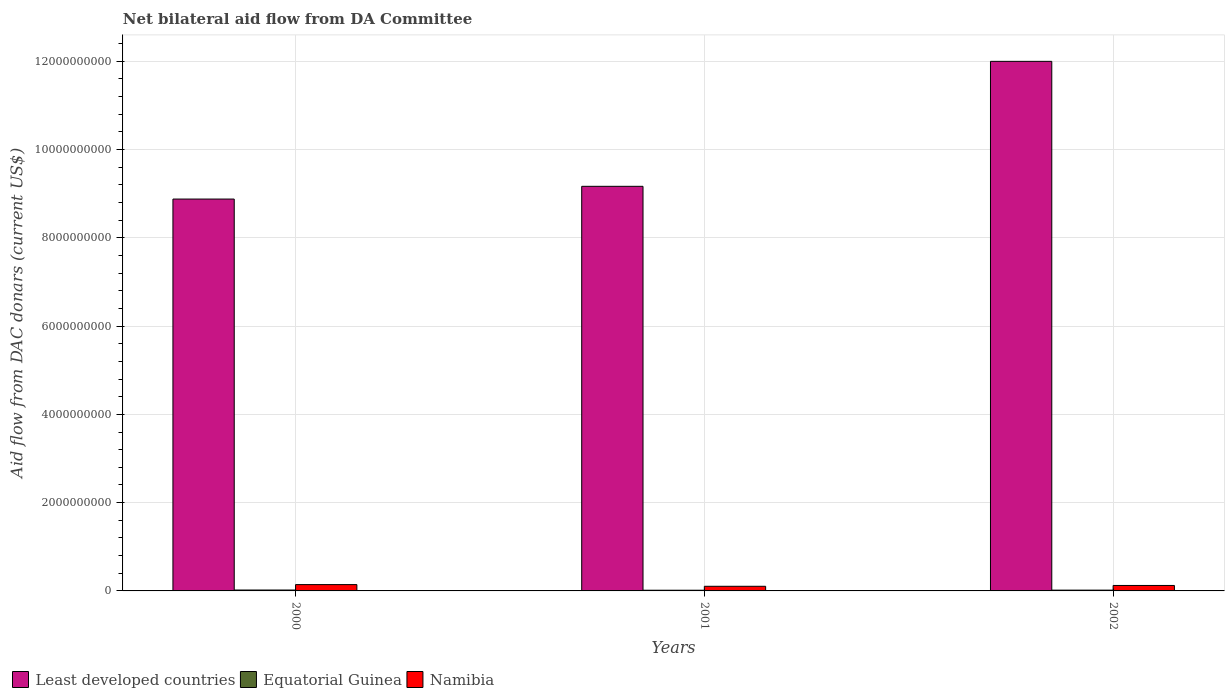How many groups of bars are there?
Offer a very short reply. 3. Are the number of bars per tick equal to the number of legend labels?
Provide a succinct answer. Yes. Are the number of bars on each tick of the X-axis equal?
Make the answer very short. Yes. How many bars are there on the 2nd tick from the left?
Offer a terse response. 3. What is the label of the 1st group of bars from the left?
Your response must be concise. 2000. In how many cases, is the number of bars for a given year not equal to the number of legend labels?
Your response must be concise. 0. What is the aid flow in in Equatorial Guinea in 2002?
Your answer should be compact. 1.77e+07. Across all years, what is the maximum aid flow in in Equatorial Guinea?
Provide a succinct answer. 2.03e+07. Across all years, what is the minimum aid flow in in Equatorial Guinea?
Keep it short and to the point. 1.57e+07. In which year was the aid flow in in Namibia maximum?
Ensure brevity in your answer.  2000. What is the total aid flow in in Least developed countries in the graph?
Your answer should be very brief. 3.00e+1. What is the difference between the aid flow in in Least developed countries in 2001 and that in 2002?
Your answer should be very brief. -2.83e+09. What is the difference between the aid flow in in Least developed countries in 2001 and the aid flow in in Equatorial Guinea in 2002?
Make the answer very short. 9.15e+09. What is the average aid flow in in Equatorial Guinea per year?
Your answer should be compact. 1.79e+07. In the year 2000, what is the difference between the aid flow in in Namibia and aid flow in in Equatorial Guinea?
Keep it short and to the point. 1.23e+08. What is the ratio of the aid flow in in Least developed countries in 2000 to that in 2002?
Your answer should be very brief. 0.74. Is the aid flow in in Equatorial Guinea in 2000 less than that in 2001?
Keep it short and to the point. No. Is the difference between the aid flow in in Namibia in 2001 and 2002 greater than the difference between the aid flow in in Equatorial Guinea in 2001 and 2002?
Provide a succinct answer. No. What is the difference between the highest and the second highest aid flow in in Least developed countries?
Offer a very short reply. 2.83e+09. What is the difference between the highest and the lowest aid flow in in Least developed countries?
Offer a terse response. 3.12e+09. In how many years, is the aid flow in in Least developed countries greater than the average aid flow in in Least developed countries taken over all years?
Make the answer very short. 1. Is the sum of the aid flow in in Equatorial Guinea in 2001 and 2002 greater than the maximum aid flow in in Least developed countries across all years?
Give a very brief answer. No. What does the 1st bar from the left in 2000 represents?
Keep it short and to the point. Least developed countries. What does the 1st bar from the right in 2002 represents?
Make the answer very short. Namibia. Is it the case that in every year, the sum of the aid flow in in Least developed countries and aid flow in in Equatorial Guinea is greater than the aid flow in in Namibia?
Ensure brevity in your answer.  Yes. Are all the bars in the graph horizontal?
Your answer should be very brief. No. What is the difference between two consecutive major ticks on the Y-axis?
Provide a succinct answer. 2.00e+09. Are the values on the major ticks of Y-axis written in scientific E-notation?
Make the answer very short. No. Does the graph contain any zero values?
Offer a very short reply. No. Where does the legend appear in the graph?
Ensure brevity in your answer.  Bottom left. How are the legend labels stacked?
Make the answer very short. Horizontal. What is the title of the graph?
Make the answer very short. Net bilateral aid flow from DA Committee. Does "Sudan" appear as one of the legend labels in the graph?
Offer a very short reply. No. What is the label or title of the Y-axis?
Make the answer very short. Aid flow from DAC donars (current US$). What is the Aid flow from DAC donars (current US$) in Least developed countries in 2000?
Give a very brief answer. 8.88e+09. What is the Aid flow from DAC donars (current US$) in Equatorial Guinea in 2000?
Provide a succinct answer. 2.03e+07. What is the Aid flow from DAC donars (current US$) in Namibia in 2000?
Your answer should be very brief. 1.43e+08. What is the Aid flow from DAC donars (current US$) of Least developed countries in 2001?
Your answer should be compact. 9.17e+09. What is the Aid flow from DAC donars (current US$) in Equatorial Guinea in 2001?
Give a very brief answer. 1.57e+07. What is the Aid flow from DAC donars (current US$) in Namibia in 2001?
Give a very brief answer. 1.05e+08. What is the Aid flow from DAC donars (current US$) in Least developed countries in 2002?
Your response must be concise. 1.20e+1. What is the Aid flow from DAC donars (current US$) of Equatorial Guinea in 2002?
Offer a very short reply. 1.77e+07. What is the Aid flow from DAC donars (current US$) in Namibia in 2002?
Make the answer very short. 1.24e+08. Across all years, what is the maximum Aid flow from DAC donars (current US$) of Least developed countries?
Make the answer very short. 1.20e+1. Across all years, what is the maximum Aid flow from DAC donars (current US$) in Equatorial Guinea?
Keep it short and to the point. 2.03e+07. Across all years, what is the maximum Aid flow from DAC donars (current US$) in Namibia?
Keep it short and to the point. 1.43e+08. Across all years, what is the minimum Aid flow from DAC donars (current US$) in Least developed countries?
Offer a terse response. 8.88e+09. Across all years, what is the minimum Aid flow from DAC donars (current US$) of Equatorial Guinea?
Provide a short and direct response. 1.57e+07. Across all years, what is the minimum Aid flow from DAC donars (current US$) in Namibia?
Your response must be concise. 1.05e+08. What is the total Aid flow from DAC donars (current US$) of Least developed countries in the graph?
Offer a terse response. 3.00e+1. What is the total Aid flow from DAC donars (current US$) of Equatorial Guinea in the graph?
Provide a short and direct response. 5.37e+07. What is the total Aid flow from DAC donars (current US$) of Namibia in the graph?
Your answer should be compact. 3.71e+08. What is the difference between the Aid flow from DAC donars (current US$) of Least developed countries in 2000 and that in 2001?
Offer a very short reply. -2.89e+08. What is the difference between the Aid flow from DAC donars (current US$) in Equatorial Guinea in 2000 and that in 2001?
Provide a succinct answer. 4.56e+06. What is the difference between the Aid flow from DAC donars (current US$) in Namibia in 2000 and that in 2001?
Your answer should be compact. 3.83e+07. What is the difference between the Aid flow from DAC donars (current US$) of Least developed countries in 2000 and that in 2002?
Offer a very short reply. -3.12e+09. What is the difference between the Aid flow from DAC donars (current US$) of Equatorial Guinea in 2000 and that in 2002?
Offer a terse response. 2.55e+06. What is the difference between the Aid flow from DAC donars (current US$) in Namibia in 2000 and that in 2002?
Provide a succinct answer. 1.95e+07. What is the difference between the Aid flow from DAC donars (current US$) of Least developed countries in 2001 and that in 2002?
Your response must be concise. -2.83e+09. What is the difference between the Aid flow from DAC donars (current US$) of Equatorial Guinea in 2001 and that in 2002?
Offer a very short reply. -2.01e+06. What is the difference between the Aid flow from DAC donars (current US$) of Namibia in 2001 and that in 2002?
Ensure brevity in your answer.  -1.88e+07. What is the difference between the Aid flow from DAC donars (current US$) in Least developed countries in 2000 and the Aid flow from DAC donars (current US$) in Equatorial Guinea in 2001?
Keep it short and to the point. 8.86e+09. What is the difference between the Aid flow from DAC donars (current US$) of Least developed countries in 2000 and the Aid flow from DAC donars (current US$) of Namibia in 2001?
Provide a succinct answer. 8.77e+09. What is the difference between the Aid flow from DAC donars (current US$) of Equatorial Guinea in 2000 and the Aid flow from DAC donars (current US$) of Namibia in 2001?
Your answer should be very brief. -8.45e+07. What is the difference between the Aid flow from DAC donars (current US$) of Least developed countries in 2000 and the Aid flow from DAC donars (current US$) of Equatorial Guinea in 2002?
Offer a terse response. 8.86e+09. What is the difference between the Aid flow from DAC donars (current US$) in Least developed countries in 2000 and the Aid flow from DAC donars (current US$) in Namibia in 2002?
Ensure brevity in your answer.  8.75e+09. What is the difference between the Aid flow from DAC donars (current US$) in Equatorial Guinea in 2000 and the Aid flow from DAC donars (current US$) in Namibia in 2002?
Provide a short and direct response. -1.03e+08. What is the difference between the Aid flow from DAC donars (current US$) in Least developed countries in 2001 and the Aid flow from DAC donars (current US$) in Equatorial Guinea in 2002?
Your answer should be compact. 9.15e+09. What is the difference between the Aid flow from DAC donars (current US$) of Least developed countries in 2001 and the Aid flow from DAC donars (current US$) of Namibia in 2002?
Offer a very short reply. 9.04e+09. What is the difference between the Aid flow from DAC donars (current US$) in Equatorial Guinea in 2001 and the Aid flow from DAC donars (current US$) in Namibia in 2002?
Keep it short and to the point. -1.08e+08. What is the average Aid flow from DAC donars (current US$) of Least developed countries per year?
Provide a short and direct response. 1.00e+1. What is the average Aid flow from DAC donars (current US$) in Equatorial Guinea per year?
Give a very brief answer. 1.79e+07. What is the average Aid flow from DAC donars (current US$) in Namibia per year?
Give a very brief answer. 1.24e+08. In the year 2000, what is the difference between the Aid flow from DAC donars (current US$) of Least developed countries and Aid flow from DAC donars (current US$) of Equatorial Guinea?
Keep it short and to the point. 8.86e+09. In the year 2000, what is the difference between the Aid flow from DAC donars (current US$) in Least developed countries and Aid flow from DAC donars (current US$) in Namibia?
Provide a short and direct response. 8.74e+09. In the year 2000, what is the difference between the Aid flow from DAC donars (current US$) in Equatorial Guinea and Aid flow from DAC donars (current US$) in Namibia?
Your response must be concise. -1.23e+08. In the year 2001, what is the difference between the Aid flow from DAC donars (current US$) in Least developed countries and Aid flow from DAC donars (current US$) in Equatorial Guinea?
Make the answer very short. 9.15e+09. In the year 2001, what is the difference between the Aid flow from DAC donars (current US$) of Least developed countries and Aid flow from DAC donars (current US$) of Namibia?
Provide a short and direct response. 9.06e+09. In the year 2001, what is the difference between the Aid flow from DAC donars (current US$) of Equatorial Guinea and Aid flow from DAC donars (current US$) of Namibia?
Your answer should be very brief. -8.91e+07. In the year 2002, what is the difference between the Aid flow from DAC donars (current US$) in Least developed countries and Aid flow from DAC donars (current US$) in Equatorial Guinea?
Provide a short and direct response. 1.20e+1. In the year 2002, what is the difference between the Aid flow from DAC donars (current US$) in Least developed countries and Aid flow from DAC donars (current US$) in Namibia?
Your answer should be compact. 1.19e+1. In the year 2002, what is the difference between the Aid flow from DAC donars (current US$) of Equatorial Guinea and Aid flow from DAC donars (current US$) of Namibia?
Give a very brief answer. -1.06e+08. What is the ratio of the Aid flow from DAC donars (current US$) in Least developed countries in 2000 to that in 2001?
Provide a succinct answer. 0.97. What is the ratio of the Aid flow from DAC donars (current US$) of Equatorial Guinea in 2000 to that in 2001?
Ensure brevity in your answer.  1.29. What is the ratio of the Aid flow from DAC donars (current US$) in Namibia in 2000 to that in 2001?
Your answer should be very brief. 1.37. What is the ratio of the Aid flow from DAC donars (current US$) of Least developed countries in 2000 to that in 2002?
Give a very brief answer. 0.74. What is the ratio of the Aid flow from DAC donars (current US$) of Equatorial Guinea in 2000 to that in 2002?
Keep it short and to the point. 1.14. What is the ratio of the Aid flow from DAC donars (current US$) of Namibia in 2000 to that in 2002?
Keep it short and to the point. 1.16. What is the ratio of the Aid flow from DAC donars (current US$) of Least developed countries in 2001 to that in 2002?
Your answer should be very brief. 0.76. What is the ratio of the Aid flow from DAC donars (current US$) in Equatorial Guinea in 2001 to that in 2002?
Your response must be concise. 0.89. What is the ratio of the Aid flow from DAC donars (current US$) in Namibia in 2001 to that in 2002?
Provide a succinct answer. 0.85. What is the difference between the highest and the second highest Aid flow from DAC donars (current US$) in Least developed countries?
Ensure brevity in your answer.  2.83e+09. What is the difference between the highest and the second highest Aid flow from DAC donars (current US$) in Equatorial Guinea?
Keep it short and to the point. 2.55e+06. What is the difference between the highest and the second highest Aid flow from DAC donars (current US$) of Namibia?
Offer a very short reply. 1.95e+07. What is the difference between the highest and the lowest Aid flow from DAC donars (current US$) in Least developed countries?
Provide a succinct answer. 3.12e+09. What is the difference between the highest and the lowest Aid flow from DAC donars (current US$) in Equatorial Guinea?
Ensure brevity in your answer.  4.56e+06. What is the difference between the highest and the lowest Aid flow from DAC donars (current US$) in Namibia?
Your answer should be very brief. 3.83e+07. 